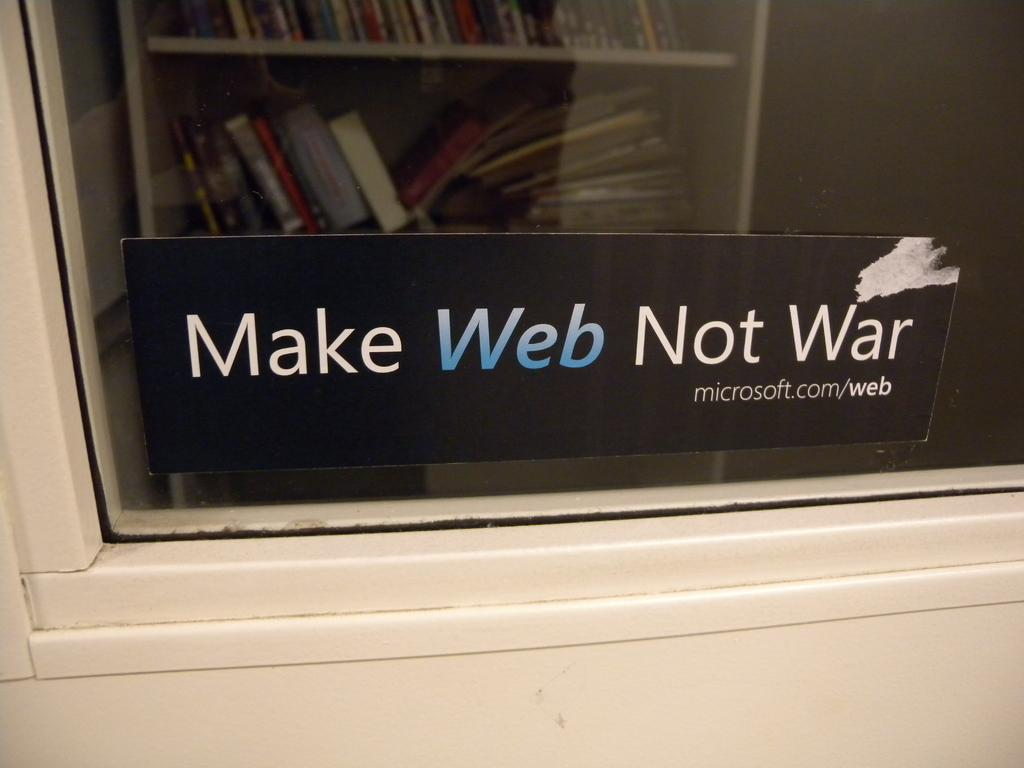Provide a one-sentence caption for the provided image. A Microsoft slogan says to "make web not war". 